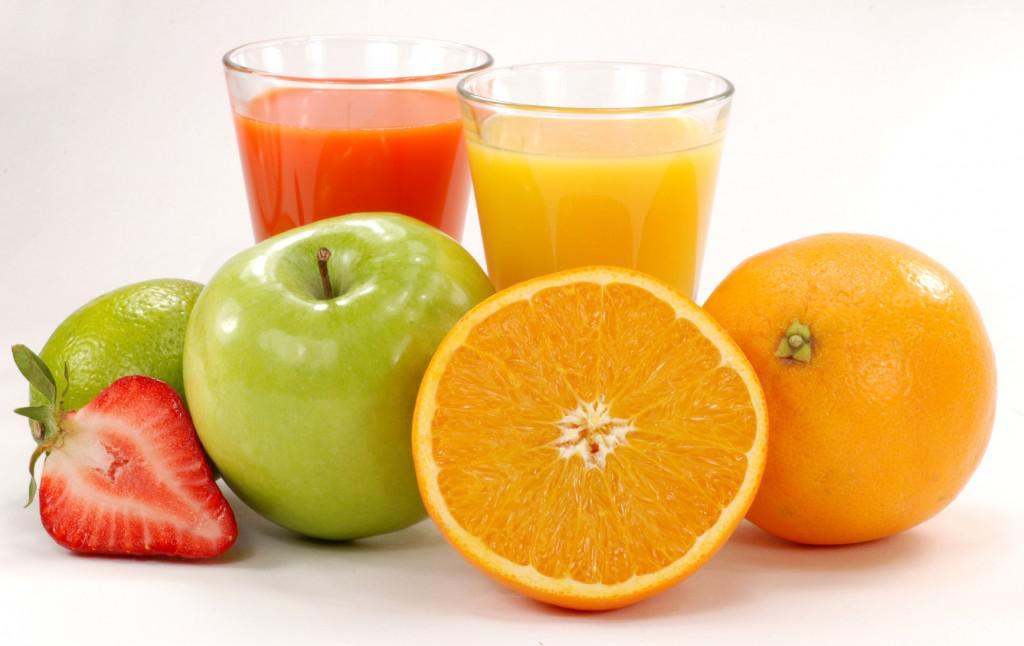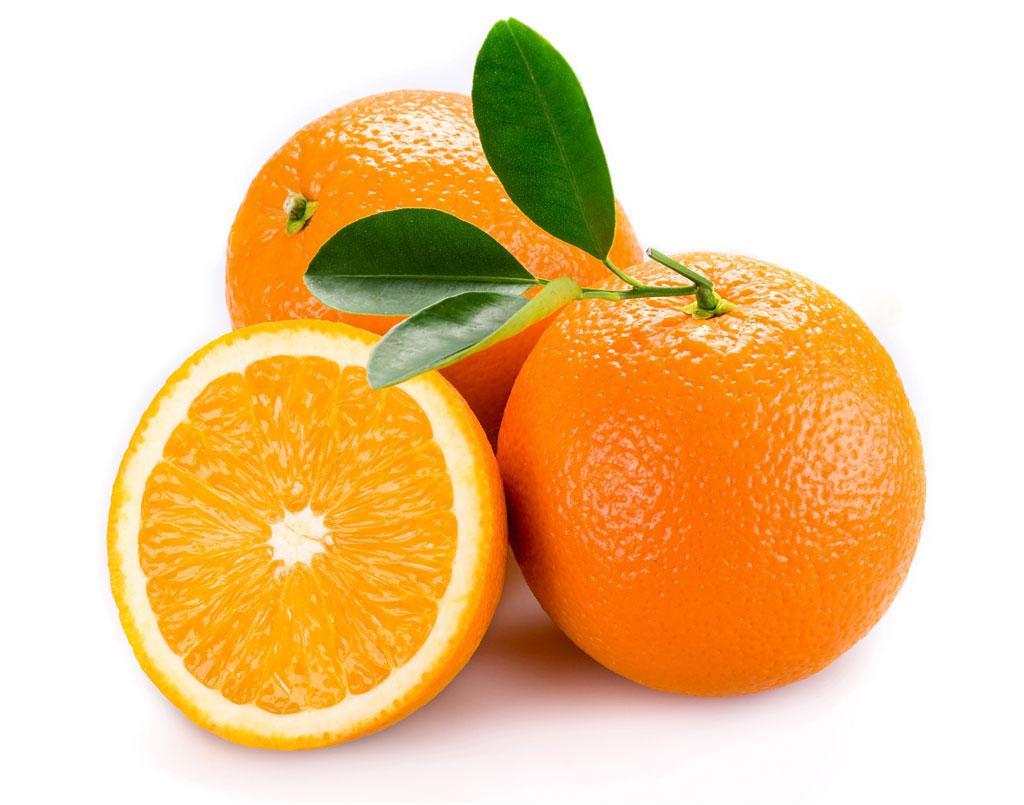The first image is the image on the left, the second image is the image on the right. Given the left and right images, does the statement "At least one of the oranges still has its stem and leaves attached to it." hold true? Answer yes or no. Yes. The first image is the image on the left, the second image is the image on the right. For the images displayed, is the sentence "Each image includes one glass containing an orange beverage and one wedge of orange." factually correct? Answer yes or no. No. 